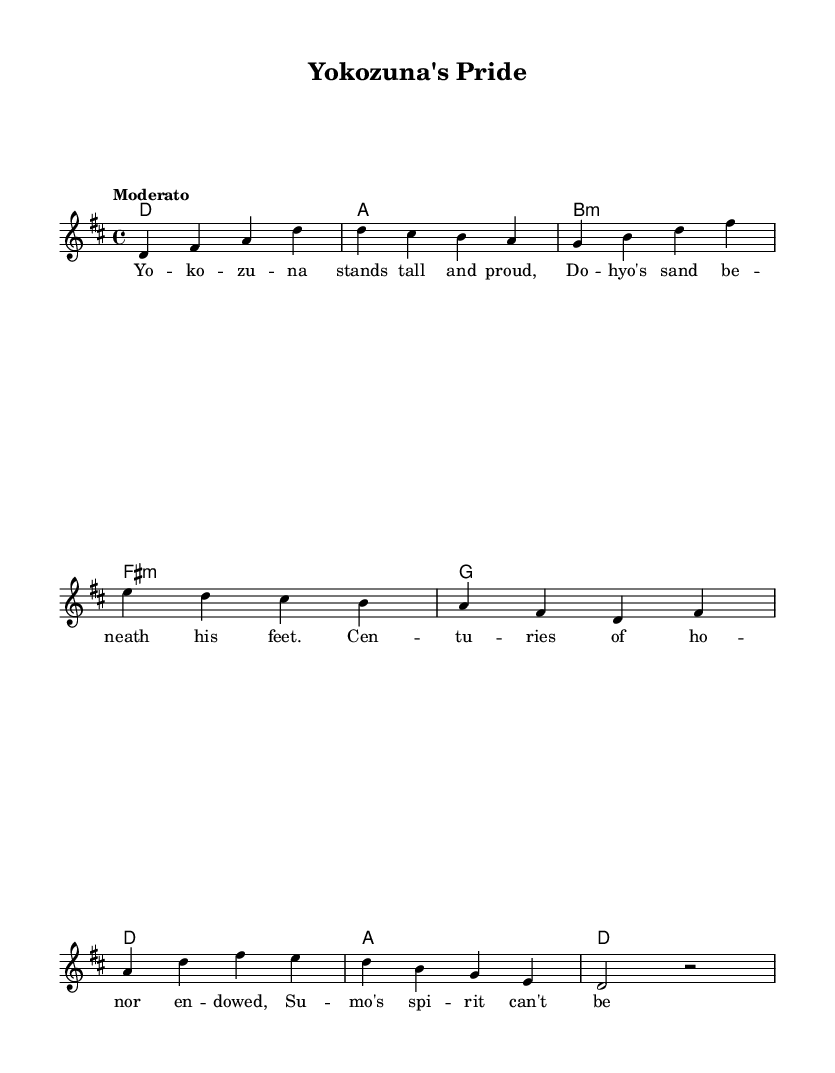What is the key signature of this music? The key signature indicated in the music is D major, which has two sharps (F# and C#). This can be confirmed by looking at the key signature shown at the beginning of the staff.
Answer: D major What is the time signature of this piece? The time signature displayed at the beginning of the music is 4/4, meaning there are four beats in each measure, and the quarter note gets one beat. This is found right after the key signature.
Answer: 4/4 What is the tempo marking for this song? The tempo marking is indicated as "Moderato," which suggests a moderate speed for the performance of the piece. This is located at the beginning of the score.
Answer: Moderato How many measures are in the melody? The melody consists of 8 measures, as counted from the start to the end of the melody section. Each measure is separated by vertical bar lines in the sheet music.
Answer: 8 What chord is played in the first measure? The chord played in the first measure is D major, represented by the symbol ‘d’ on the chord staff. This is indicated in the chord section at the start of the piece.
Answer: D major What is the last note of the melody? The last note in the melody is a half note, indicated by the ‘r’ symbol (rest) which implies it is not played, but if we consider the last sounding pitch before that, it is ‘d’ held for two beats. The last played note is found before the rest at the end of the melody.
Answer: d What lyrical themes are described in the verse? The verse describes themes of pride and honor associated with the sumo culture, specifically highlighting the strength of the yokozuna and the tradition inherent in sumo. This can be interpreted from the lyrics provided under the melody.
Answer: Pride and honor 